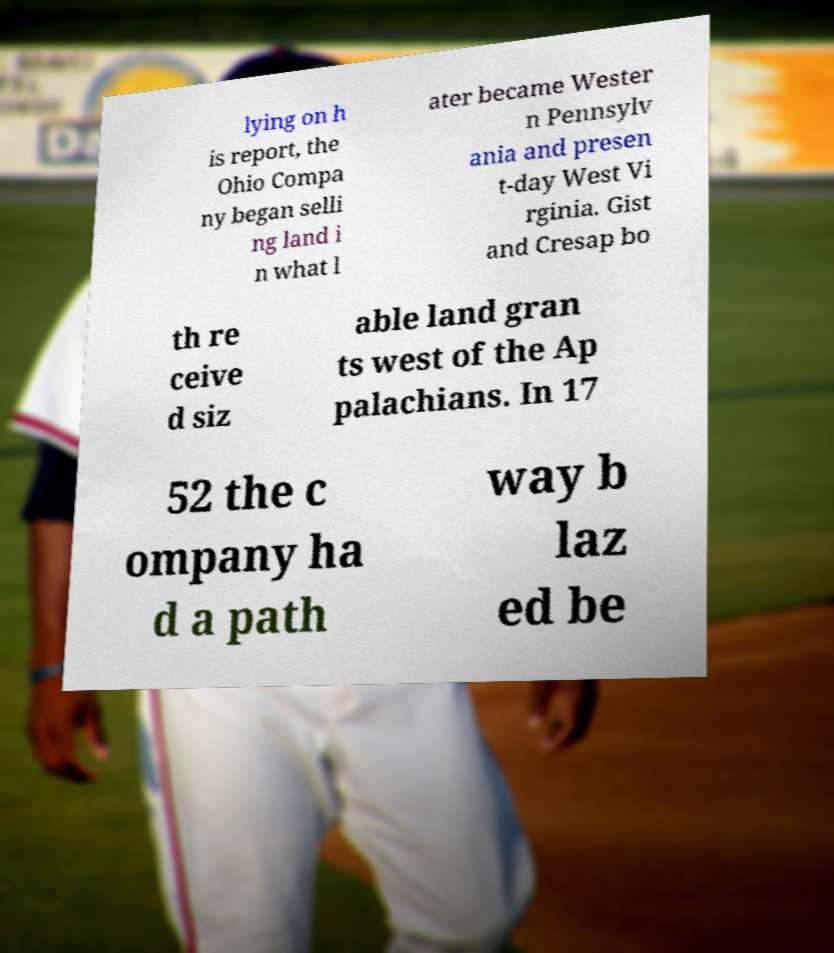Can you read and provide the text displayed in the image?This photo seems to have some interesting text. Can you extract and type it out for me? lying on h is report, the Ohio Compa ny began selli ng land i n what l ater became Wester n Pennsylv ania and presen t-day West Vi rginia. Gist and Cresap bo th re ceive d siz able land gran ts west of the Ap palachians. In 17 52 the c ompany ha d a path way b laz ed be 